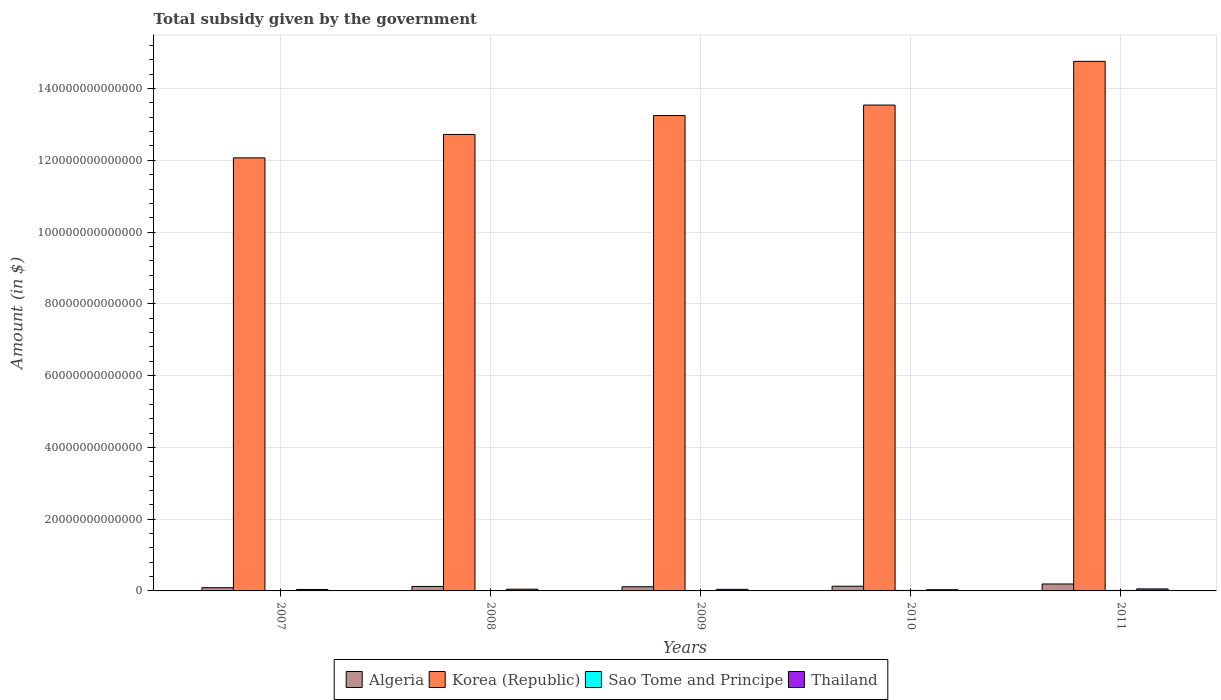How many different coloured bars are there?
Provide a short and direct response. 4. Are the number of bars per tick equal to the number of legend labels?
Make the answer very short. Yes. Are the number of bars on each tick of the X-axis equal?
Your answer should be compact. Yes. How many bars are there on the 2nd tick from the left?
Provide a succinct answer. 4. What is the label of the 1st group of bars from the left?
Provide a succinct answer. 2007. What is the total revenue collected by the government in Korea (Republic) in 2009?
Your answer should be compact. 1.32e+14. Across all years, what is the maximum total revenue collected by the government in Thailand?
Your answer should be compact. 5.55e+11. Across all years, what is the minimum total revenue collected by the government in Algeria?
Make the answer very short. 9.00e+11. In which year was the total revenue collected by the government in Thailand maximum?
Your answer should be compact. 2011. What is the total total revenue collected by the government in Algeria in the graph?
Ensure brevity in your answer.  6.55e+12. What is the difference between the total revenue collected by the government in Algeria in 2008 and that in 2009?
Offer a very short reply. 8.71e+1. What is the difference between the total revenue collected by the government in Sao Tome and Principe in 2007 and the total revenue collected by the government in Korea (Republic) in 2008?
Your answer should be very brief. -1.27e+14. What is the average total revenue collected by the government in Korea (Republic) per year?
Offer a terse response. 1.33e+14. In the year 2008, what is the difference between the total revenue collected by the government in Korea (Republic) and total revenue collected by the government in Algeria?
Ensure brevity in your answer.  1.26e+14. What is the ratio of the total revenue collected by the government in Sao Tome and Principe in 2007 to that in 2010?
Give a very brief answer. 0.69. Is the total revenue collected by the government in Thailand in 2009 less than that in 2011?
Give a very brief answer. Yes. Is the difference between the total revenue collected by the government in Korea (Republic) in 2007 and 2008 greater than the difference between the total revenue collected by the government in Algeria in 2007 and 2008?
Make the answer very short. No. What is the difference between the highest and the second highest total revenue collected by the government in Sao Tome and Principe?
Offer a very short reply. 2.07e+09. What is the difference between the highest and the lowest total revenue collected by the government in Algeria?
Your answer should be compact. 1.03e+12. Is the sum of the total revenue collected by the government in Thailand in 2009 and 2011 greater than the maximum total revenue collected by the government in Sao Tome and Principe across all years?
Offer a very short reply. Yes. Is it the case that in every year, the sum of the total revenue collected by the government in Algeria and total revenue collected by the government in Korea (Republic) is greater than the sum of total revenue collected by the government in Thailand and total revenue collected by the government in Sao Tome and Principe?
Keep it short and to the point. Yes. What does the 1st bar from the left in 2009 represents?
Make the answer very short. Algeria. What does the 4th bar from the right in 2008 represents?
Ensure brevity in your answer.  Algeria. Is it the case that in every year, the sum of the total revenue collected by the government in Algeria and total revenue collected by the government in Thailand is greater than the total revenue collected by the government in Sao Tome and Principe?
Offer a terse response. Yes. What is the difference between two consecutive major ticks on the Y-axis?
Offer a very short reply. 2.00e+13. Does the graph contain any zero values?
Give a very brief answer. No. Does the graph contain grids?
Ensure brevity in your answer.  Yes. Where does the legend appear in the graph?
Provide a short and direct response. Bottom center. How many legend labels are there?
Your answer should be compact. 4. What is the title of the graph?
Ensure brevity in your answer.  Total subsidy given by the government. Does "Turkmenistan" appear as one of the legend labels in the graph?
Provide a succinct answer. No. What is the label or title of the Y-axis?
Provide a short and direct response. Amount (in $). What is the Amount (in $) of Algeria in 2007?
Keep it short and to the point. 9.00e+11. What is the Amount (in $) in Korea (Republic) in 2007?
Offer a very short reply. 1.21e+14. What is the Amount (in $) of Sao Tome and Principe in 2007?
Ensure brevity in your answer.  9.39e+1. What is the Amount (in $) in Thailand in 2007?
Provide a short and direct response. 4.09e+11. What is the Amount (in $) in Algeria in 2008?
Your response must be concise. 1.25e+12. What is the Amount (in $) in Korea (Republic) in 2008?
Give a very brief answer. 1.27e+14. What is the Amount (in $) in Sao Tome and Principe in 2008?
Your answer should be very brief. 6.06e+1. What is the Amount (in $) in Thailand in 2008?
Make the answer very short. 4.70e+11. What is the Amount (in $) of Algeria in 2009?
Your answer should be very brief. 1.16e+12. What is the Amount (in $) of Korea (Republic) in 2009?
Your response must be concise. 1.32e+14. What is the Amount (in $) of Sao Tome and Principe in 2009?
Provide a succinct answer. 9.66e+1. What is the Amount (in $) of Thailand in 2009?
Provide a succinct answer. 4.43e+11. What is the Amount (in $) in Algeria in 2010?
Your answer should be compact. 1.31e+12. What is the Amount (in $) in Korea (Republic) in 2010?
Provide a succinct answer. 1.35e+14. What is the Amount (in $) of Sao Tome and Principe in 2010?
Offer a terse response. 1.37e+11. What is the Amount (in $) of Thailand in 2010?
Your answer should be very brief. 3.35e+11. What is the Amount (in $) in Algeria in 2011?
Provide a short and direct response. 1.93e+12. What is the Amount (in $) of Korea (Republic) in 2011?
Ensure brevity in your answer.  1.48e+14. What is the Amount (in $) in Sao Tome and Principe in 2011?
Offer a very short reply. 1.39e+11. What is the Amount (in $) of Thailand in 2011?
Your answer should be compact. 5.55e+11. Across all years, what is the maximum Amount (in $) of Algeria?
Your answer should be very brief. 1.93e+12. Across all years, what is the maximum Amount (in $) of Korea (Republic)?
Keep it short and to the point. 1.48e+14. Across all years, what is the maximum Amount (in $) of Sao Tome and Principe?
Your answer should be very brief. 1.39e+11. Across all years, what is the maximum Amount (in $) of Thailand?
Your answer should be very brief. 5.55e+11. Across all years, what is the minimum Amount (in $) of Algeria?
Ensure brevity in your answer.  9.00e+11. Across all years, what is the minimum Amount (in $) of Korea (Republic)?
Keep it short and to the point. 1.21e+14. Across all years, what is the minimum Amount (in $) of Sao Tome and Principe?
Your response must be concise. 6.06e+1. Across all years, what is the minimum Amount (in $) of Thailand?
Provide a succinct answer. 3.35e+11. What is the total Amount (in $) of Algeria in the graph?
Give a very brief answer. 6.55e+12. What is the total Amount (in $) of Korea (Republic) in the graph?
Provide a short and direct response. 6.63e+14. What is the total Amount (in $) of Sao Tome and Principe in the graph?
Keep it short and to the point. 5.27e+11. What is the total Amount (in $) of Thailand in the graph?
Ensure brevity in your answer.  2.21e+12. What is the difference between the Amount (in $) of Algeria in 2007 and that in 2008?
Your answer should be compact. -3.47e+11. What is the difference between the Amount (in $) of Korea (Republic) in 2007 and that in 2008?
Your response must be concise. -6.53e+12. What is the difference between the Amount (in $) in Sao Tome and Principe in 2007 and that in 2008?
Your answer should be compact. 3.34e+1. What is the difference between the Amount (in $) in Thailand in 2007 and that in 2008?
Keep it short and to the point. -6.11e+1. What is the difference between the Amount (in $) in Algeria in 2007 and that in 2009?
Offer a terse response. -2.60e+11. What is the difference between the Amount (in $) of Korea (Republic) in 2007 and that in 2009?
Your answer should be very brief. -1.18e+13. What is the difference between the Amount (in $) of Sao Tome and Principe in 2007 and that in 2009?
Provide a succinct answer. -2.74e+09. What is the difference between the Amount (in $) of Thailand in 2007 and that in 2009?
Make the answer very short. -3.37e+1. What is the difference between the Amount (in $) in Algeria in 2007 and that in 2010?
Your response must be concise. -4.06e+11. What is the difference between the Amount (in $) in Korea (Republic) in 2007 and that in 2010?
Keep it short and to the point. -1.47e+13. What is the difference between the Amount (in $) of Sao Tome and Principe in 2007 and that in 2010?
Your response must be concise. -4.29e+1. What is the difference between the Amount (in $) in Thailand in 2007 and that in 2010?
Your response must be concise. 7.47e+1. What is the difference between the Amount (in $) in Algeria in 2007 and that in 2011?
Your response must be concise. -1.03e+12. What is the difference between the Amount (in $) in Korea (Republic) in 2007 and that in 2011?
Provide a succinct answer. -2.69e+13. What is the difference between the Amount (in $) in Sao Tome and Principe in 2007 and that in 2011?
Offer a very short reply. -4.50e+1. What is the difference between the Amount (in $) in Thailand in 2007 and that in 2011?
Provide a succinct answer. -1.46e+11. What is the difference between the Amount (in $) in Algeria in 2008 and that in 2009?
Make the answer very short. 8.71e+1. What is the difference between the Amount (in $) in Korea (Republic) in 2008 and that in 2009?
Provide a short and direct response. -5.26e+12. What is the difference between the Amount (in $) of Sao Tome and Principe in 2008 and that in 2009?
Offer a terse response. -3.61e+1. What is the difference between the Amount (in $) in Thailand in 2008 and that in 2009?
Offer a very short reply. 2.74e+1. What is the difference between the Amount (in $) of Algeria in 2008 and that in 2010?
Offer a very short reply. -5.92e+1. What is the difference between the Amount (in $) of Korea (Republic) in 2008 and that in 2010?
Ensure brevity in your answer.  -8.19e+12. What is the difference between the Amount (in $) in Sao Tome and Principe in 2008 and that in 2010?
Provide a short and direct response. -7.63e+1. What is the difference between the Amount (in $) in Thailand in 2008 and that in 2010?
Give a very brief answer. 1.36e+11. What is the difference between the Amount (in $) in Algeria in 2008 and that in 2011?
Offer a terse response. -6.88e+11. What is the difference between the Amount (in $) in Korea (Republic) in 2008 and that in 2011?
Ensure brevity in your answer.  -2.04e+13. What is the difference between the Amount (in $) in Sao Tome and Principe in 2008 and that in 2011?
Your response must be concise. -7.84e+1. What is the difference between the Amount (in $) of Thailand in 2008 and that in 2011?
Keep it short and to the point. -8.49e+1. What is the difference between the Amount (in $) of Algeria in 2009 and that in 2010?
Keep it short and to the point. -1.46e+11. What is the difference between the Amount (in $) of Korea (Republic) in 2009 and that in 2010?
Your answer should be compact. -2.93e+12. What is the difference between the Amount (in $) in Sao Tome and Principe in 2009 and that in 2010?
Your answer should be compact. -4.02e+1. What is the difference between the Amount (in $) in Thailand in 2009 and that in 2010?
Give a very brief answer. 1.08e+11. What is the difference between the Amount (in $) of Algeria in 2009 and that in 2011?
Your response must be concise. -7.75e+11. What is the difference between the Amount (in $) in Korea (Republic) in 2009 and that in 2011?
Give a very brief answer. -1.51e+13. What is the difference between the Amount (in $) of Sao Tome and Principe in 2009 and that in 2011?
Keep it short and to the point. -4.23e+1. What is the difference between the Amount (in $) in Thailand in 2009 and that in 2011?
Ensure brevity in your answer.  -1.12e+11. What is the difference between the Amount (in $) in Algeria in 2010 and that in 2011?
Your answer should be very brief. -6.28e+11. What is the difference between the Amount (in $) in Korea (Republic) in 2010 and that in 2011?
Your answer should be very brief. -1.22e+13. What is the difference between the Amount (in $) of Sao Tome and Principe in 2010 and that in 2011?
Your response must be concise. -2.07e+09. What is the difference between the Amount (in $) in Thailand in 2010 and that in 2011?
Your answer should be very brief. -2.21e+11. What is the difference between the Amount (in $) of Algeria in 2007 and the Amount (in $) of Korea (Republic) in 2008?
Offer a very short reply. -1.26e+14. What is the difference between the Amount (in $) of Algeria in 2007 and the Amount (in $) of Sao Tome and Principe in 2008?
Keep it short and to the point. 8.39e+11. What is the difference between the Amount (in $) of Algeria in 2007 and the Amount (in $) of Thailand in 2008?
Your answer should be very brief. 4.29e+11. What is the difference between the Amount (in $) in Korea (Republic) in 2007 and the Amount (in $) in Sao Tome and Principe in 2008?
Keep it short and to the point. 1.21e+14. What is the difference between the Amount (in $) in Korea (Republic) in 2007 and the Amount (in $) in Thailand in 2008?
Your answer should be compact. 1.20e+14. What is the difference between the Amount (in $) of Sao Tome and Principe in 2007 and the Amount (in $) of Thailand in 2008?
Keep it short and to the point. -3.76e+11. What is the difference between the Amount (in $) in Algeria in 2007 and the Amount (in $) in Korea (Republic) in 2009?
Offer a terse response. -1.32e+14. What is the difference between the Amount (in $) in Algeria in 2007 and the Amount (in $) in Sao Tome and Principe in 2009?
Your answer should be compact. 8.03e+11. What is the difference between the Amount (in $) in Algeria in 2007 and the Amount (in $) in Thailand in 2009?
Give a very brief answer. 4.57e+11. What is the difference between the Amount (in $) of Korea (Republic) in 2007 and the Amount (in $) of Sao Tome and Principe in 2009?
Your response must be concise. 1.21e+14. What is the difference between the Amount (in $) in Korea (Republic) in 2007 and the Amount (in $) in Thailand in 2009?
Provide a succinct answer. 1.20e+14. What is the difference between the Amount (in $) in Sao Tome and Principe in 2007 and the Amount (in $) in Thailand in 2009?
Provide a succinct answer. -3.49e+11. What is the difference between the Amount (in $) in Algeria in 2007 and the Amount (in $) in Korea (Republic) in 2010?
Make the answer very short. -1.34e+14. What is the difference between the Amount (in $) of Algeria in 2007 and the Amount (in $) of Sao Tome and Principe in 2010?
Your answer should be compact. 7.63e+11. What is the difference between the Amount (in $) of Algeria in 2007 and the Amount (in $) of Thailand in 2010?
Your answer should be very brief. 5.65e+11. What is the difference between the Amount (in $) in Korea (Republic) in 2007 and the Amount (in $) in Sao Tome and Principe in 2010?
Your answer should be compact. 1.21e+14. What is the difference between the Amount (in $) of Korea (Republic) in 2007 and the Amount (in $) of Thailand in 2010?
Keep it short and to the point. 1.20e+14. What is the difference between the Amount (in $) in Sao Tome and Principe in 2007 and the Amount (in $) in Thailand in 2010?
Keep it short and to the point. -2.41e+11. What is the difference between the Amount (in $) in Algeria in 2007 and the Amount (in $) in Korea (Republic) in 2011?
Your answer should be very brief. -1.47e+14. What is the difference between the Amount (in $) of Algeria in 2007 and the Amount (in $) of Sao Tome and Principe in 2011?
Keep it short and to the point. 7.61e+11. What is the difference between the Amount (in $) of Algeria in 2007 and the Amount (in $) of Thailand in 2011?
Provide a short and direct response. 3.45e+11. What is the difference between the Amount (in $) of Korea (Republic) in 2007 and the Amount (in $) of Sao Tome and Principe in 2011?
Offer a very short reply. 1.21e+14. What is the difference between the Amount (in $) in Korea (Republic) in 2007 and the Amount (in $) in Thailand in 2011?
Provide a short and direct response. 1.20e+14. What is the difference between the Amount (in $) in Sao Tome and Principe in 2007 and the Amount (in $) in Thailand in 2011?
Keep it short and to the point. -4.61e+11. What is the difference between the Amount (in $) in Algeria in 2008 and the Amount (in $) in Korea (Republic) in 2009?
Provide a succinct answer. -1.31e+14. What is the difference between the Amount (in $) in Algeria in 2008 and the Amount (in $) in Sao Tome and Principe in 2009?
Your answer should be very brief. 1.15e+12. What is the difference between the Amount (in $) in Algeria in 2008 and the Amount (in $) in Thailand in 2009?
Provide a succinct answer. 8.04e+11. What is the difference between the Amount (in $) in Korea (Republic) in 2008 and the Amount (in $) in Sao Tome and Principe in 2009?
Give a very brief answer. 1.27e+14. What is the difference between the Amount (in $) of Korea (Republic) in 2008 and the Amount (in $) of Thailand in 2009?
Keep it short and to the point. 1.27e+14. What is the difference between the Amount (in $) of Sao Tome and Principe in 2008 and the Amount (in $) of Thailand in 2009?
Provide a succinct answer. -3.82e+11. What is the difference between the Amount (in $) in Algeria in 2008 and the Amount (in $) in Korea (Republic) in 2010?
Provide a short and direct response. -1.34e+14. What is the difference between the Amount (in $) of Algeria in 2008 and the Amount (in $) of Sao Tome and Principe in 2010?
Offer a very short reply. 1.11e+12. What is the difference between the Amount (in $) in Algeria in 2008 and the Amount (in $) in Thailand in 2010?
Provide a succinct answer. 9.13e+11. What is the difference between the Amount (in $) in Korea (Republic) in 2008 and the Amount (in $) in Sao Tome and Principe in 2010?
Provide a succinct answer. 1.27e+14. What is the difference between the Amount (in $) of Korea (Republic) in 2008 and the Amount (in $) of Thailand in 2010?
Provide a succinct answer. 1.27e+14. What is the difference between the Amount (in $) in Sao Tome and Principe in 2008 and the Amount (in $) in Thailand in 2010?
Your answer should be very brief. -2.74e+11. What is the difference between the Amount (in $) in Algeria in 2008 and the Amount (in $) in Korea (Republic) in 2011?
Offer a very short reply. -1.46e+14. What is the difference between the Amount (in $) in Algeria in 2008 and the Amount (in $) in Sao Tome and Principe in 2011?
Provide a short and direct response. 1.11e+12. What is the difference between the Amount (in $) in Algeria in 2008 and the Amount (in $) in Thailand in 2011?
Keep it short and to the point. 6.92e+11. What is the difference between the Amount (in $) in Korea (Republic) in 2008 and the Amount (in $) in Sao Tome and Principe in 2011?
Your response must be concise. 1.27e+14. What is the difference between the Amount (in $) in Korea (Republic) in 2008 and the Amount (in $) in Thailand in 2011?
Provide a short and direct response. 1.27e+14. What is the difference between the Amount (in $) of Sao Tome and Principe in 2008 and the Amount (in $) of Thailand in 2011?
Your answer should be compact. -4.95e+11. What is the difference between the Amount (in $) in Algeria in 2009 and the Amount (in $) in Korea (Republic) in 2010?
Ensure brevity in your answer.  -1.34e+14. What is the difference between the Amount (in $) of Algeria in 2009 and the Amount (in $) of Sao Tome and Principe in 2010?
Make the answer very short. 1.02e+12. What is the difference between the Amount (in $) in Algeria in 2009 and the Amount (in $) in Thailand in 2010?
Offer a very short reply. 8.25e+11. What is the difference between the Amount (in $) of Korea (Republic) in 2009 and the Amount (in $) of Sao Tome and Principe in 2010?
Make the answer very short. 1.32e+14. What is the difference between the Amount (in $) in Korea (Republic) in 2009 and the Amount (in $) in Thailand in 2010?
Keep it short and to the point. 1.32e+14. What is the difference between the Amount (in $) in Sao Tome and Principe in 2009 and the Amount (in $) in Thailand in 2010?
Your answer should be compact. -2.38e+11. What is the difference between the Amount (in $) in Algeria in 2009 and the Amount (in $) in Korea (Republic) in 2011?
Provide a short and direct response. -1.46e+14. What is the difference between the Amount (in $) of Algeria in 2009 and the Amount (in $) of Sao Tome and Principe in 2011?
Your answer should be compact. 1.02e+12. What is the difference between the Amount (in $) of Algeria in 2009 and the Amount (in $) of Thailand in 2011?
Give a very brief answer. 6.05e+11. What is the difference between the Amount (in $) of Korea (Republic) in 2009 and the Amount (in $) of Sao Tome and Principe in 2011?
Offer a very short reply. 1.32e+14. What is the difference between the Amount (in $) in Korea (Republic) in 2009 and the Amount (in $) in Thailand in 2011?
Offer a terse response. 1.32e+14. What is the difference between the Amount (in $) of Sao Tome and Principe in 2009 and the Amount (in $) of Thailand in 2011?
Provide a succinct answer. -4.59e+11. What is the difference between the Amount (in $) of Algeria in 2010 and the Amount (in $) of Korea (Republic) in 2011?
Provide a short and direct response. -1.46e+14. What is the difference between the Amount (in $) of Algeria in 2010 and the Amount (in $) of Sao Tome and Principe in 2011?
Your answer should be very brief. 1.17e+12. What is the difference between the Amount (in $) of Algeria in 2010 and the Amount (in $) of Thailand in 2011?
Offer a terse response. 7.51e+11. What is the difference between the Amount (in $) in Korea (Republic) in 2010 and the Amount (in $) in Sao Tome and Principe in 2011?
Offer a very short reply. 1.35e+14. What is the difference between the Amount (in $) of Korea (Republic) in 2010 and the Amount (in $) of Thailand in 2011?
Your answer should be compact. 1.35e+14. What is the difference between the Amount (in $) of Sao Tome and Principe in 2010 and the Amount (in $) of Thailand in 2011?
Offer a very short reply. -4.18e+11. What is the average Amount (in $) of Algeria per year?
Your answer should be compact. 1.31e+12. What is the average Amount (in $) in Korea (Republic) per year?
Your answer should be very brief. 1.33e+14. What is the average Amount (in $) of Sao Tome and Principe per year?
Keep it short and to the point. 1.05e+11. What is the average Amount (in $) of Thailand per year?
Make the answer very short. 4.43e+11. In the year 2007, what is the difference between the Amount (in $) of Algeria and Amount (in $) of Korea (Republic)?
Your answer should be compact. -1.20e+14. In the year 2007, what is the difference between the Amount (in $) of Algeria and Amount (in $) of Sao Tome and Principe?
Keep it short and to the point. 8.06e+11. In the year 2007, what is the difference between the Amount (in $) in Algeria and Amount (in $) in Thailand?
Provide a succinct answer. 4.90e+11. In the year 2007, what is the difference between the Amount (in $) in Korea (Republic) and Amount (in $) in Sao Tome and Principe?
Your answer should be compact. 1.21e+14. In the year 2007, what is the difference between the Amount (in $) of Korea (Republic) and Amount (in $) of Thailand?
Make the answer very short. 1.20e+14. In the year 2007, what is the difference between the Amount (in $) of Sao Tome and Principe and Amount (in $) of Thailand?
Provide a succinct answer. -3.15e+11. In the year 2008, what is the difference between the Amount (in $) of Algeria and Amount (in $) of Korea (Republic)?
Keep it short and to the point. -1.26e+14. In the year 2008, what is the difference between the Amount (in $) of Algeria and Amount (in $) of Sao Tome and Principe?
Your answer should be compact. 1.19e+12. In the year 2008, what is the difference between the Amount (in $) of Algeria and Amount (in $) of Thailand?
Your answer should be very brief. 7.77e+11. In the year 2008, what is the difference between the Amount (in $) in Korea (Republic) and Amount (in $) in Sao Tome and Principe?
Offer a terse response. 1.27e+14. In the year 2008, what is the difference between the Amount (in $) in Korea (Republic) and Amount (in $) in Thailand?
Make the answer very short. 1.27e+14. In the year 2008, what is the difference between the Amount (in $) in Sao Tome and Principe and Amount (in $) in Thailand?
Ensure brevity in your answer.  -4.10e+11. In the year 2009, what is the difference between the Amount (in $) of Algeria and Amount (in $) of Korea (Republic)?
Your answer should be compact. -1.31e+14. In the year 2009, what is the difference between the Amount (in $) of Algeria and Amount (in $) of Sao Tome and Principe?
Offer a terse response. 1.06e+12. In the year 2009, what is the difference between the Amount (in $) of Algeria and Amount (in $) of Thailand?
Offer a terse response. 7.17e+11. In the year 2009, what is the difference between the Amount (in $) of Korea (Republic) and Amount (in $) of Sao Tome and Principe?
Provide a short and direct response. 1.32e+14. In the year 2009, what is the difference between the Amount (in $) of Korea (Republic) and Amount (in $) of Thailand?
Make the answer very short. 1.32e+14. In the year 2009, what is the difference between the Amount (in $) of Sao Tome and Principe and Amount (in $) of Thailand?
Keep it short and to the point. -3.46e+11. In the year 2010, what is the difference between the Amount (in $) in Algeria and Amount (in $) in Korea (Republic)?
Your response must be concise. -1.34e+14. In the year 2010, what is the difference between the Amount (in $) in Algeria and Amount (in $) in Sao Tome and Principe?
Your answer should be very brief. 1.17e+12. In the year 2010, what is the difference between the Amount (in $) in Algeria and Amount (in $) in Thailand?
Offer a very short reply. 9.72e+11. In the year 2010, what is the difference between the Amount (in $) of Korea (Republic) and Amount (in $) of Sao Tome and Principe?
Ensure brevity in your answer.  1.35e+14. In the year 2010, what is the difference between the Amount (in $) of Korea (Republic) and Amount (in $) of Thailand?
Give a very brief answer. 1.35e+14. In the year 2010, what is the difference between the Amount (in $) in Sao Tome and Principe and Amount (in $) in Thailand?
Offer a terse response. -1.98e+11. In the year 2011, what is the difference between the Amount (in $) in Algeria and Amount (in $) in Korea (Republic)?
Provide a succinct answer. -1.46e+14. In the year 2011, what is the difference between the Amount (in $) in Algeria and Amount (in $) in Sao Tome and Principe?
Offer a very short reply. 1.80e+12. In the year 2011, what is the difference between the Amount (in $) in Algeria and Amount (in $) in Thailand?
Ensure brevity in your answer.  1.38e+12. In the year 2011, what is the difference between the Amount (in $) in Korea (Republic) and Amount (in $) in Sao Tome and Principe?
Offer a terse response. 1.47e+14. In the year 2011, what is the difference between the Amount (in $) of Korea (Republic) and Amount (in $) of Thailand?
Your answer should be compact. 1.47e+14. In the year 2011, what is the difference between the Amount (in $) of Sao Tome and Principe and Amount (in $) of Thailand?
Provide a short and direct response. -4.16e+11. What is the ratio of the Amount (in $) in Algeria in 2007 to that in 2008?
Give a very brief answer. 0.72. What is the ratio of the Amount (in $) in Korea (Republic) in 2007 to that in 2008?
Give a very brief answer. 0.95. What is the ratio of the Amount (in $) of Sao Tome and Principe in 2007 to that in 2008?
Offer a very short reply. 1.55. What is the ratio of the Amount (in $) of Thailand in 2007 to that in 2008?
Provide a short and direct response. 0.87. What is the ratio of the Amount (in $) in Algeria in 2007 to that in 2009?
Your answer should be very brief. 0.78. What is the ratio of the Amount (in $) in Korea (Republic) in 2007 to that in 2009?
Ensure brevity in your answer.  0.91. What is the ratio of the Amount (in $) in Sao Tome and Principe in 2007 to that in 2009?
Offer a terse response. 0.97. What is the ratio of the Amount (in $) of Thailand in 2007 to that in 2009?
Make the answer very short. 0.92. What is the ratio of the Amount (in $) in Algeria in 2007 to that in 2010?
Your answer should be very brief. 0.69. What is the ratio of the Amount (in $) of Korea (Republic) in 2007 to that in 2010?
Your answer should be very brief. 0.89. What is the ratio of the Amount (in $) in Sao Tome and Principe in 2007 to that in 2010?
Ensure brevity in your answer.  0.69. What is the ratio of the Amount (in $) in Thailand in 2007 to that in 2010?
Offer a very short reply. 1.22. What is the ratio of the Amount (in $) of Algeria in 2007 to that in 2011?
Your response must be concise. 0.47. What is the ratio of the Amount (in $) in Korea (Republic) in 2007 to that in 2011?
Your answer should be very brief. 0.82. What is the ratio of the Amount (in $) in Sao Tome and Principe in 2007 to that in 2011?
Ensure brevity in your answer.  0.68. What is the ratio of the Amount (in $) of Thailand in 2007 to that in 2011?
Provide a short and direct response. 0.74. What is the ratio of the Amount (in $) in Algeria in 2008 to that in 2009?
Your response must be concise. 1.08. What is the ratio of the Amount (in $) in Korea (Republic) in 2008 to that in 2009?
Ensure brevity in your answer.  0.96. What is the ratio of the Amount (in $) of Sao Tome and Principe in 2008 to that in 2009?
Your answer should be compact. 0.63. What is the ratio of the Amount (in $) in Thailand in 2008 to that in 2009?
Offer a terse response. 1.06. What is the ratio of the Amount (in $) in Algeria in 2008 to that in 2010?
Provide a succinct answer. 0.95. What is the ratio of the Amount (in $) in Korea (Republic) in 2008 to that in 2010?
Your response must be concise. 0.94. What is the ratio of the Amount (in $) of Sao Tome and Principe in 2008 to that in 2010?
Offer a very short reply. 0.44. What is the ratio of the Amount (in $) of Thailand in 2008 to that in 2010?
Provide a succinct answer. 1.41. What is the ratio of the Amount (in $) of Algeria in 2008 to that in 2011?
Offer a very short reply. 0.64. What is the ratio of the Amount (in $) in Korea (Republic) in 2008 to that in 2011?
Ensure brevity in your answer.  0.86. What is the ratio of the Amount (in $) of Sao Tome and Principe in 2008 to that in 2011?
Offer a terse response. 0.44. What is the ratio of the Amount (in $) in Thailand in 2008 to that in 2011?
Your response must be concise. 0.85. What is the ratio of the Amount (in $) in Algeria in 2009 to that in 2010?
Your answer should be compact. 0.89. What is the ratio of the Amount (in $) in Korea (Republic) in 2009 to that in 2010?
Your answer should be very brief. 0.98. What is the ratio of the Amount (in $) in Sao Tome and Principe in 2009 to that in 2010?
Provide a succinct answer. 0.71. What is the ratio of the Amount (in $) in Thailand in 2009 to that in 2010?
Provide a succinct answer. 1.32. What is the ratio of the Amount (in $) in Algeria in 2009 to that in 2011?
Ensure brevity in your answer.  0.6. What is the ratio of the Amount (in $) of Korea (Republic) in 2009 to that in 2011?
Provide a succinct answer. 0.9. What is the ratio of the Amount (in $) of Sao Tome and Principe in 2009 to that in 2011?
Make the answer very short. 0.7. What is the ratio of the Amount (in $) of Thailand in 2009 to that in 2011?
Keep it short and to the point. 0.8. What is the ratio of the Amount (in $) of Algeria in 2010 to that in 2011?
Provide a succinct answer. 0.68. What is the ratio of the Amount (in $) of Korea (Republic) in 2010 to that in 2011?
Make the answer very short. 0.92. What is the ratio of the Amount (in $) of Sao Tome and Principe in 2010 to that in 2011?
Offer a very short reply. 0.99. What is the ratio of the Amount (in $) of Thailand in 2010 to that in 2011?
Make the answer very short. 0.6. What is the difference between the highest and the second highest Amount (in $) of Algeria?
Keep it short and to the point. 6.28e+11. What is the difference between the highest and the second highest Amount (in $) in Korea (Republic)?
Offer a terse response. 1.22e+13. What is the difference between the highest and the second highest Amount (in $) of Sao Tome and Principe?
Offer a very short reply. 2.07e+09. What is the difference between the highest and the second highest Amount (in $) in Thailand?
Provide a short and direct response. 8.49e+1. What is the difference between the highest and the lowest Amount (in $) in Algeria?
Provide a short and direct response. 1.03e+12. What is the difference between the highest and the lowest Amount (in $) in Korea (Republic)?
Provide a succinct answer. 2.69e+13. What is the difference between the highest and the lowest Amount (in $) in Sao Tome and Principe?
Make the answer very short. 7.84e+1. What is the difference between the highest and the lowest Amount (in $) in Thailand?
Make the answer very short. 2.21e+11. 